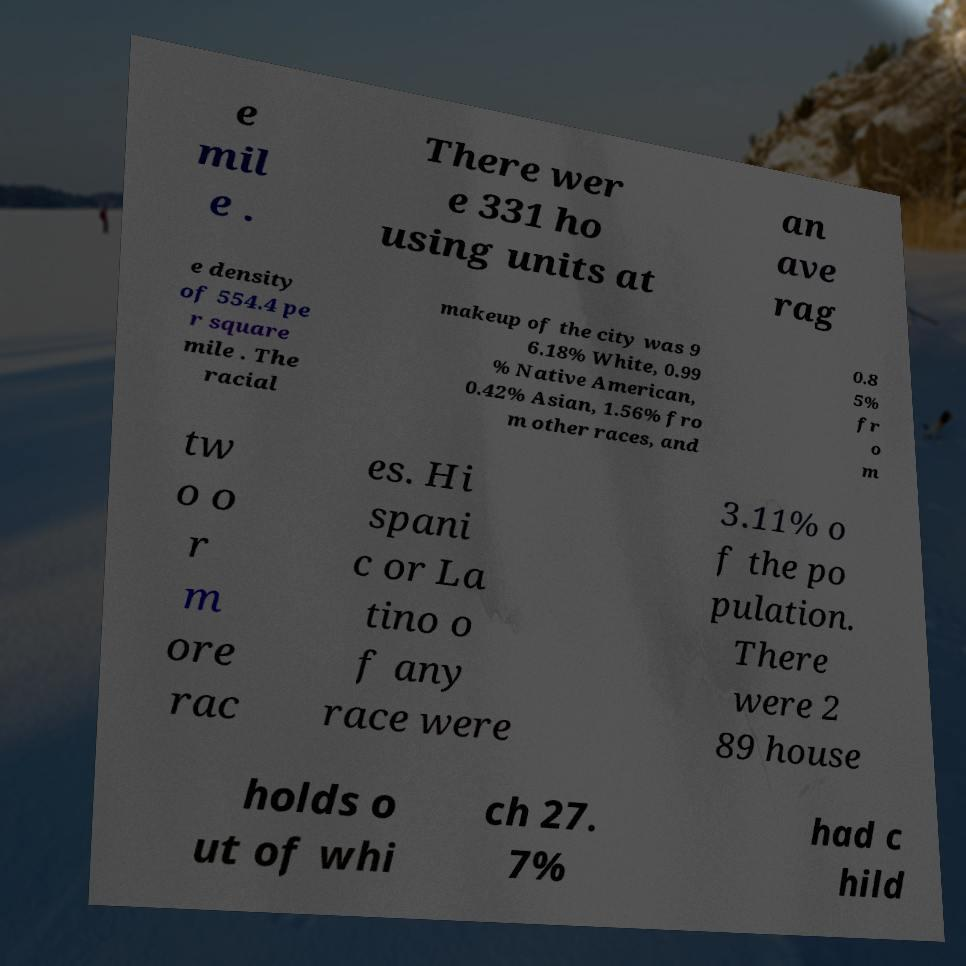Please identify and transcribe the text found in this image. e mil e . There wer e 331 ho using units at an ave rag e density of 554.4 pe r square mile . The racial makeup of the city was 9 6.18% White, 0.99 % Native American, 0.42% Asian, 1.56% fro m other races, and 0.8 5% fr o m tw o o r m ore rac es. Hi spani c or La tino o f any race were 3.11% o f the po pulation. There were 2 89 house holds o ut of whi ch 27. 7% had c hild 